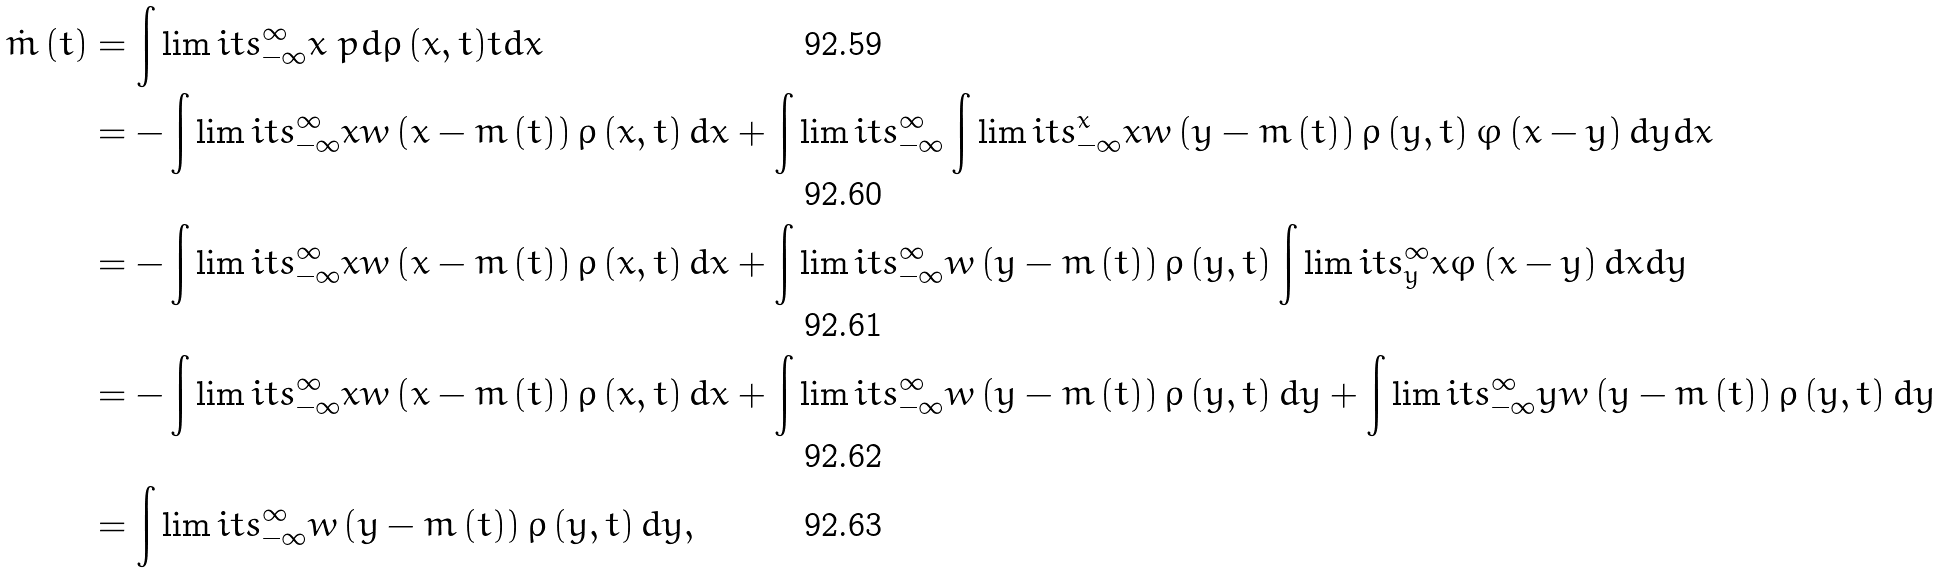<formula> <loc_0><loc_0><loc_500><loc_500>\dot { m } \left ( t \right ) & = \int \lim i t s _ { - \infty } ^ { \infty } x \ p d { \varrho \left ( x , t \right ) } { t } d x \\ & = - \int \lim i t s _ { - \infty } ^ { \infty } x w \left ( x - m \left ( t \right ) \right ) \varrho \left ( x , t \right ) d x + \int \lim i t s _ { - \infty } ^ { \infty } \int \lim i t s _ { - \infty } ^ { x } x w \left ( y - m \left ( t \right ) \right ) \varrho \left ( y , t \right ) \varphi \left ( x - y \right ) d y d x \\ & = - \int \lim i t s _ { - \infty } ^ { \infty } x w \left ( x - m \left ( t \right ) \right ) \varrho \left ( x , t \right ) d x + \int \lim i t s _ { - \infty } ^ { \infty } w \left ( y - m \left ( t \right ) \right ) \varrho \left ( y , t \right ) \int \lim i t s _ { y } ^ { \infty } x \varphi \left ( x - y \right ) d x d y \\ & = - \int \lim i t s _ { - \infty } ^ { \infty } x w \left ( x - m \left ( t \right ) \right ) \varrho \left ( x , t \right ) d x + \int \lim i t s _ { - \infty } ^ { \infty } w \left ( y - m \left ( t \right ) \right ) \varrho \left ( y , t \right ) d y + \int \lim i t s _ { - \infty } ^ { \infty } y w \left ( y - m \left ( t \right ) \right ) \varrho \left ( y , t \right ) d y \\ & = \int \lim i t s _ { - \infty } ^ { \infty } w \left ( y - m \left ( t \right ) \right ) \varrho \left ( y , t \right ) d y ,</formula> 